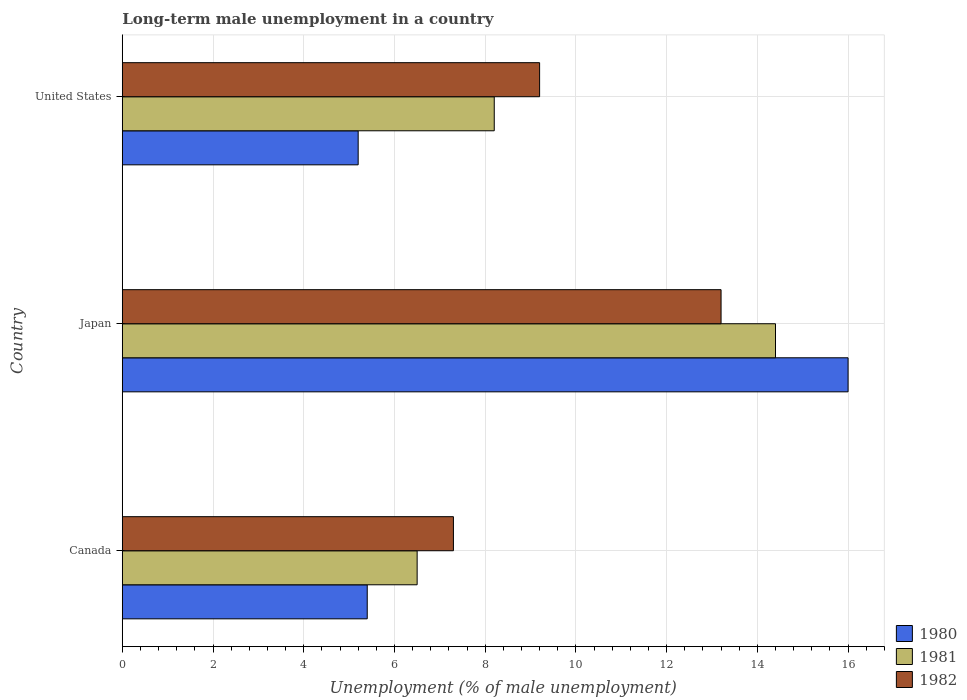How many different coloured bars are there?
Provide a short and direct response. 3. How many groups of bars are there?
Offer a very short reply. 3. How many bars are there on the 2nd tick from the top?
Provide a short and direct response. 3. What is the percentage of long-term unemployed male population in 1980 in United States?
Offer a terse response. 5.2. Across all countries, what is the maximum percentage of long-term unemployed male population in 1980?
Give a very brief answer. 16. Across all countries, what is the minimum percentage of long-term unemployed male population in 1980?
Your answer should be very brief. 5.2. In which country was the percentage of long-term unemployed male population in 1981 maximum?
Provide a short and direct response. Japan. What is the total percentage of long-term unemployed male population in 1980 in the graph?
Your response must be concise. 26.6. What is the difference between the percentage of long-term unemployed male population in 1980 in Japan and that in United States?
Provide a succinct answer. 10.8. What is the difference between the percentage of long-term unemployed male population in 1980 in Japan and the percentage of long-term unemployed male population in 1981 in United States?
Keep it short and to the point. 7.8. What is the average percentage of long-term unemployed male population in 1981 per country?
Ensure brevity in your answer.  9.7. What is the difference between the percentage of long-term unemployed male population in 1980 and percentage of long-term unemployed male population in 1981 in United States?
Ensure brevity in your answer.  -3. What is the ratio of the percentage of long-term unemployed male population in 1981 in Canada to that in Japan?
Your answer should be very brief. 0.45. Is the difference between the percentage of long-term unemployed male population in 1980 in Canada and United States greater than the difference between the percentage of long-term unemployed male population in 1981 in Canada and United States?
Your response must be concise. Yes. What is the difference between the highest and the second highest percentage of long-term unemployed male population in 1982?
Your response must be concise. 4. What is the difference between the highest and the lowest percentage of long-term unemployed male population in 1980?
Your response must be concise. 10.8. How many countries are there in the graph?
Provide a succinct answer. 3. Does the graph contain any zero values?
Your response must be concise. No. Where does the legend appear in the graph?
Provide a short and direct response. Bottom right. What is the title of the graph?
Keep it short and to the point. Long-term male unemployment in a country. What is the label or title of the X-axis?
Keep it short and to the point. Unemployment (% of male unemployment). What is the Unemployment (% of male unemployment) of 1980 in Canada?
Your response must be concise. 5.4. What is the Unemployment (% of male unemployment) in 1982 in Canada?
Your answer should be compact. 7.3. What is the Unemployment (% of male unemployment) in 1981 in Japan?
Keep it short and to the point. 14.4. What is the Unemployment (% of male unemployment) of 1982 in Japan?
Your answer should be compact. 13.2. What is the Unemployment (% of male unemployment) in 1980 in United States?
Give a very brief answer. 5.2. What is the Unemployment (% of male unemployment) in 1981 in United States?
Give a very brief answer. 8.2. What is the Unemployment (% of male unemployment) of 1982 in United States?
Offer a terse response. 9.2. Across all countries, what is the maximum Unemployment (% of male unemployment) of 1981?
Ensure brevity in your answer.  14.4. Across all countries, what is the maximum Unemployment (% of male unemployment) of 1982?
Offer a terse response. 13.2. Across all countries, what is the minimum Unemployment (% of male unemployment) in 1980?
Ensure brevity in your answer.  5.2. Across all countries, what is the minimum Unemployment (% of male unemployment) of 1981?
Your response must be concise. 6.5. Across all countries, what is the minimum Unemployment (% of male unemployment) of 1982?
Offer a very short reply. 7.3. What is the total Unemployment (% of male unemployment) of 1980 in the graph?
Provide a succinct answer. 26.6. What is the total Unemployment (% of male unemployment) of 1981 in the graph?
Your response must be concise. 29.1. What is the total Unemployment (% of male unemployment) of 1982 in the graph?
Offer a very short reply. 29.7. What is the difference between the Unemployment (% of male unemployment) of 1980 in Canada and that in Japan?
Offer a terse response. -10.6. What is the difference between the Unemployment (% of male unemployment) of 1981 in Canada and that in Japan?
Your answer should be compact. -7.9. What is the difference between the Unemployment (% of male unemployment) in 1982 in Canada and that in Japan?
Your answer should be very brief. -5.9. What is the difference between the Unemployment (% of male unemployment) in 1980 in Canada and that in United States?
Your answer should be very brief. 0.2. What is the difference between the Unemployment (% of male unemployment) of 1982 in Canada and that in United States?
Give a very brief answer. -1.9. What is the difference between the Unemployment (% of male unemployment) in 1981 in Japan and that in United States?
Give a very brief answer. 6.2. What is the difference between the Unemployment (% of male unemployment) of 1982 in Japan and that in United States?
Make the answer very short. 4. What is the difference between the Unemployment (% of male unemployment) of 1980 in Canada and the Unemployment (% of male unemployment) of 1981 in Japan?
Ensure brevity in your answer.  -9. What is the difference between the Unemployment (% of male unemployment) of 1980 in Canada and the Unemployment (% of male unemployment) of 1982 in Japan?
Provide a short and direct response. -7.8. What is the difference between the Unemployment (% of male unemployment) in 1981 in Canada and the Unemployment (% of male unemployment) in 1982 in Japan?
Give a very brief answer. -6.7. What is the difference between the Unemployment (% of male unemployment) in 1980 in Canada and the Unemployment (% of male unemployment) in 1981 in United States?
Keep it short and to the point. -2.8. What is the difference between the Unemployment (% of male unemployment) in 1980 in Canada and the Unemployment (% of male unemployment) in 1982 in United States?
Keep it short and to the point. -3.8. What is the difference between the Unemployment (% of male unemployment) of 1980 in Japan and the Unemployment (% of male unemployment) of 1981 in United States?
Ensure brevity in your answer.  7.8. What is the difference between the Unemployment (% of male unemployment) of 1981 in Japan and the Unemployment (% of male unemployment) of 1982 in United States?
Make the answer very short. 5.2. What is the average Unemployment (% of male unemployment) in 1980 per country?
Offer a terse response. 8.87. What is the average Unemployment (% of male unemployment) of 1981 per country?
Offer a terse response. 9.7. What is the average Unemployment (% of male unemployment) in 1982 per country?
Your response must be concise. 9.9. What is the difference between the Unemployment (% of male unemployment) in 1981 and Unemployment (% of male unemployment) in 1982 in Canada?
Provide a succinct answer. -0.8. What is the difference between the Unemployment (% of male unemployment) in 1980 and Unemployment (% of male unemployment) in 1981 in Japan?
Your answer should be compact. 1.6. What is the difference between the Unemployment (% of male unemployment) in 1981 and Unemployment (% of male unemployment) in 1982 in Japan?
Keep it short and to the point. 1.2. What is the difference between the Unemployment (% of male unemployment) of 1980 and Unemployment (% of male unemployment) of 1981 in United States?
Provide a succinct answer. -3. What is the difference between the Unemployment (% of male unemployment) in 1980 and Unemployment (% of male unemployment) in 1982 in United States?
Provide a short and direct response. -4. What is the ratio of the Unemployment (% of male unemployment) of 1980 in Canada to that in Japan?
Your answer should be compact. 0.34. What is the ratio of the Unemployment (% of male unemployment) in 1981 in Canada to that in Japan?
Provide a short and direct response. 0.45. What is the ratio of the Unemployment (% of male unemployment) of 1982 in Canada to that in Japan?
Give a very brief answer. 0.55. What is the ratio of the Unemployment (% of male unemployment) of 1981 in Canada to that in United States?
Ensure brevity in your answer.  0.79. What is the ratio of the Unemployment (% of male unemployment) in 1982 in Canada to that in United States?
Make the answer very short. 0.79. What is the ratio of the Unemployment (% of male unemployment) in 1980 in Japan to that in United States?
Offer a very short reply. 3.08. What is the ratio of the Unemployment (% of male unemployment) in 1981 in Japan to that in United States?
Make the answer very short. 1.76. What is the ratio of the Unemployment (% of male unemployment) in 1982 in Japan to that in United States?
Provide a short and direct response. 1.43. What is the difference between the highest and the second highest Unemployment (% of male unemployment) of 1981?
Provide a short and direct response. 6.2. What is the difference between the highest and the second highest Unemployment (% of male unemployment) of 1982?
Offer a very short reply. 4. What is the difference between the highest and the lowest Unemployment (% of male unemployment) of 1980?
Ensure brevity in your answer.  10.8. What is the difference between the highest and the lowest Unemployment (% of male unemployment) of 1981?
Make the answer very short. 7.9. 